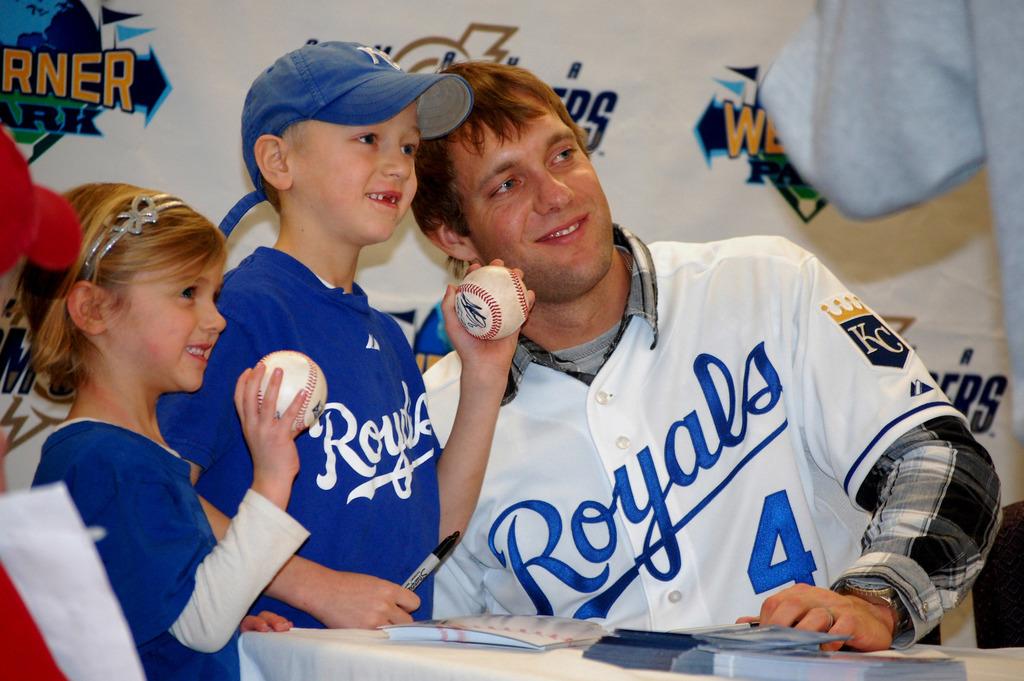What team does he play for?
Your response must be concise. Royals. 